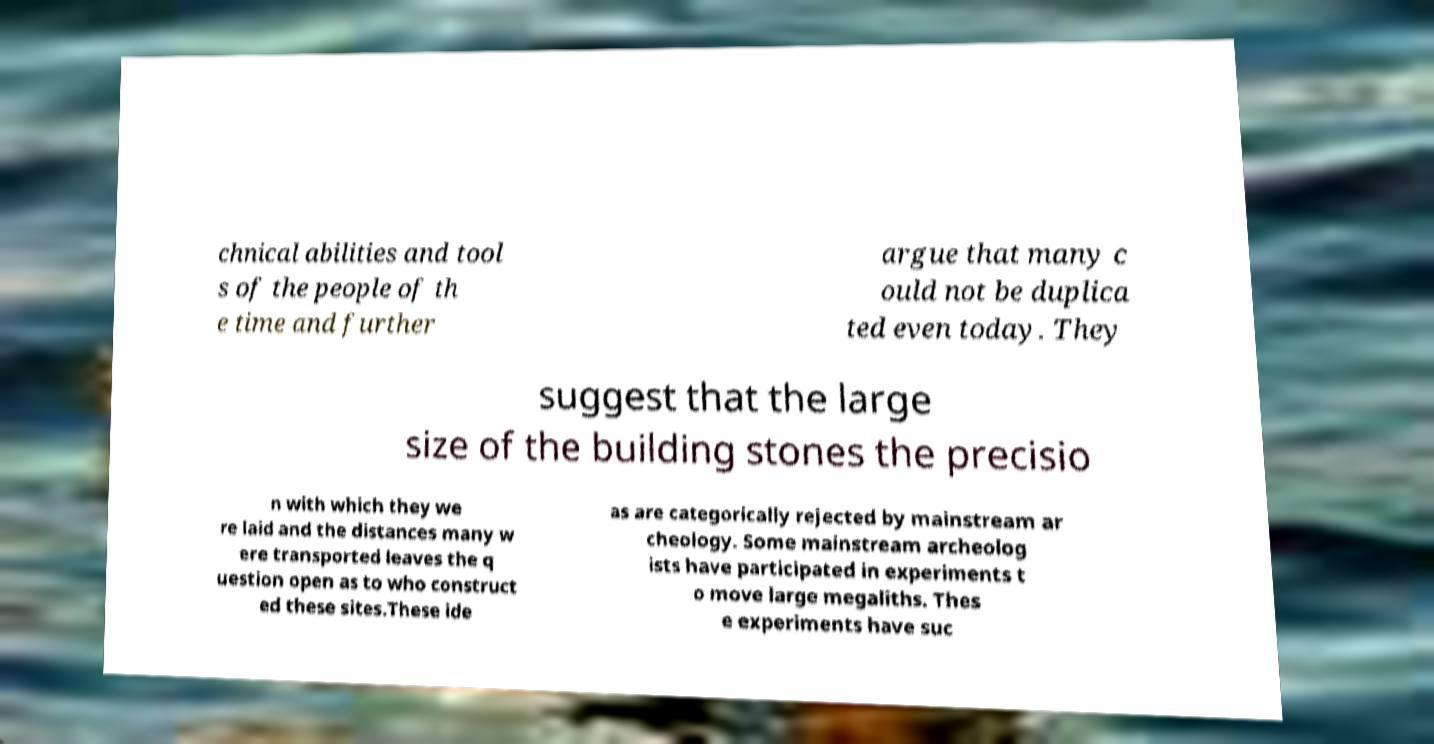I need the written content from this picture converted into text. Can you do that? chnical abilities and tool s of the people of th e time and further argue that many c ould not be duplica ted even today. They suggest that the large size of the building stones the precisio n with which they we re laid and the distances many w ere transported leaves the q uestion open as to who construct ed these sites.These ide as are categorically rejected by mainstream ar cheology. Some mainstream archeolog ists have participated in experiments t o move large megaliths. Thes e experiments have suc 